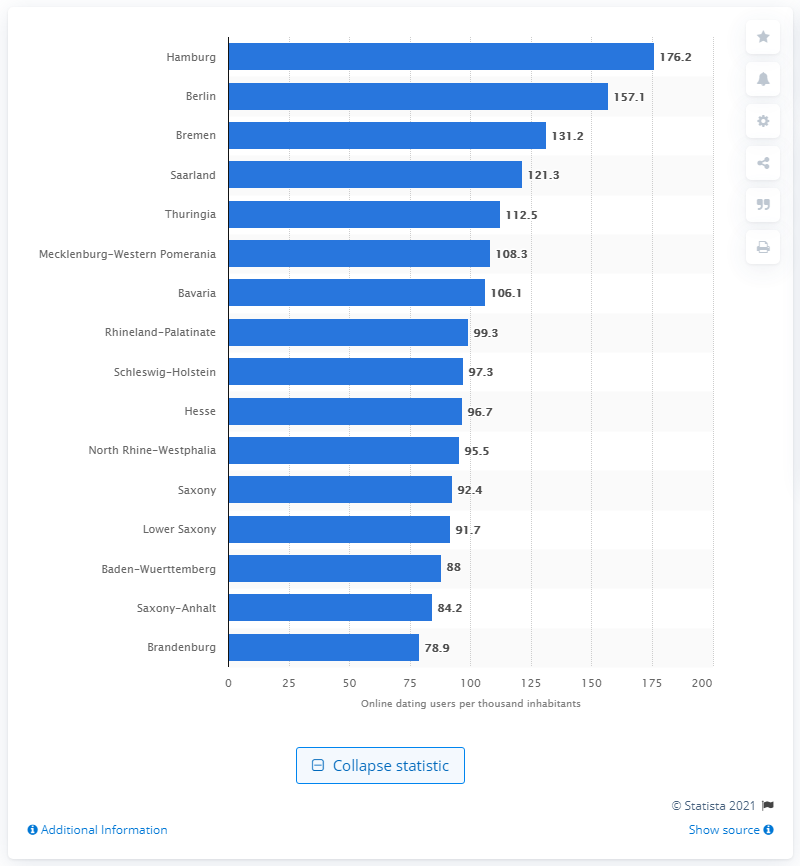Outline some significant characteristics in this image. In 2013, 157.1 people in Berlin visited online dating sites. 